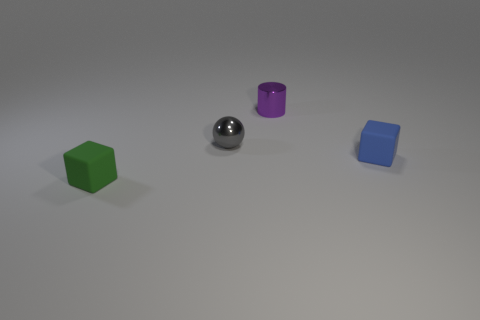Are there more cylinders that are to the right of the green cube than small cylinders left of the tiny gray object?
Your response must be concise. Yes. Is there a small blue rubber object that has the same shape as the tiny green object?
Provide a succinct answer. Yes. What shape is the rubber object that is the same size as the blue cube?
Ensure brevity in your answer.  Cube. There is a object in front of the small blue rubber block; what is its shape?
Make the answer very short. Cube. Are there fewer metal objects that are right of the purple cylinder than small objects that are in front of the small gray metallic object?
Make the answer very short. Yes. What number of other rubber cubes have the same size as the green rubber block?
Your answer should be very brief. 1. What color is the other object that is made of the same material as the small gray thing?
Offer a terse response. Purple. Is the number of tiny purple metallic things greater than the number of objects?
Provide a short and direct response. No. Do the gray ball and the purple thing have the same material?
Ensure brevity in your answer.  Yes. The object that is made of the same material as the small gray sphere is what shape?
Your answer should be very brief. Cylinder. 